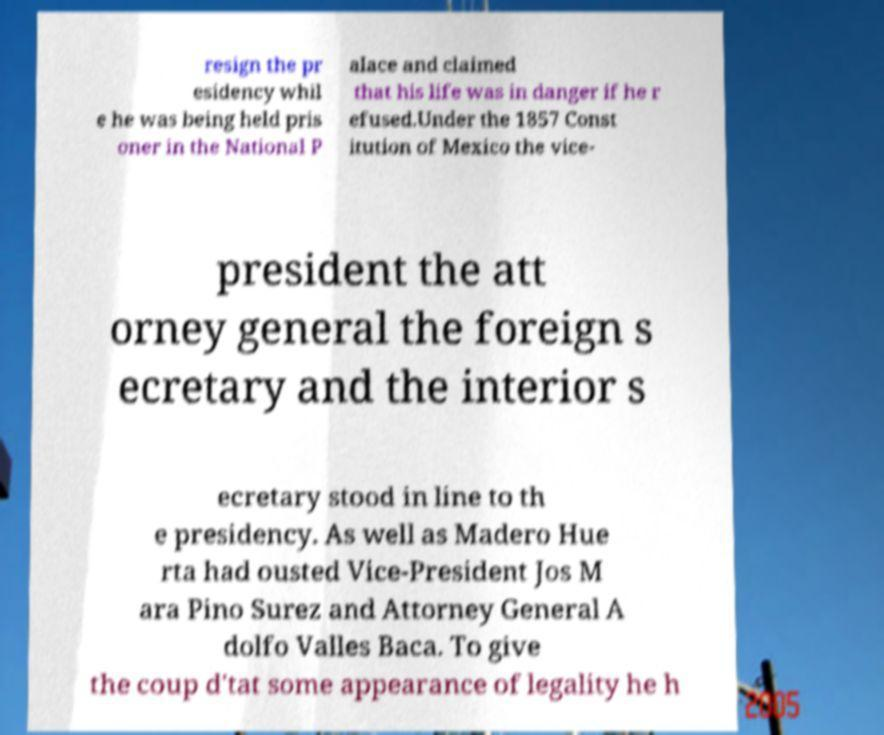I need the written content from this picture converted into text. Can you do that? resign the pr esidency whil e he was being held pris oner in the National P alace and claimed that his life was in danger if he r efused.Under the 1857 Const itution of Mexico the vice- president the att orney general the foreign s ecretary and the interior s ecretary stood in line to th e presidency. As well as Madero Hue rta had ousted Vice-President Jos M ara Pino Surez and Attorney General A dolfo Valles Baca. To give the coup d'tat some appearance of legality he h 